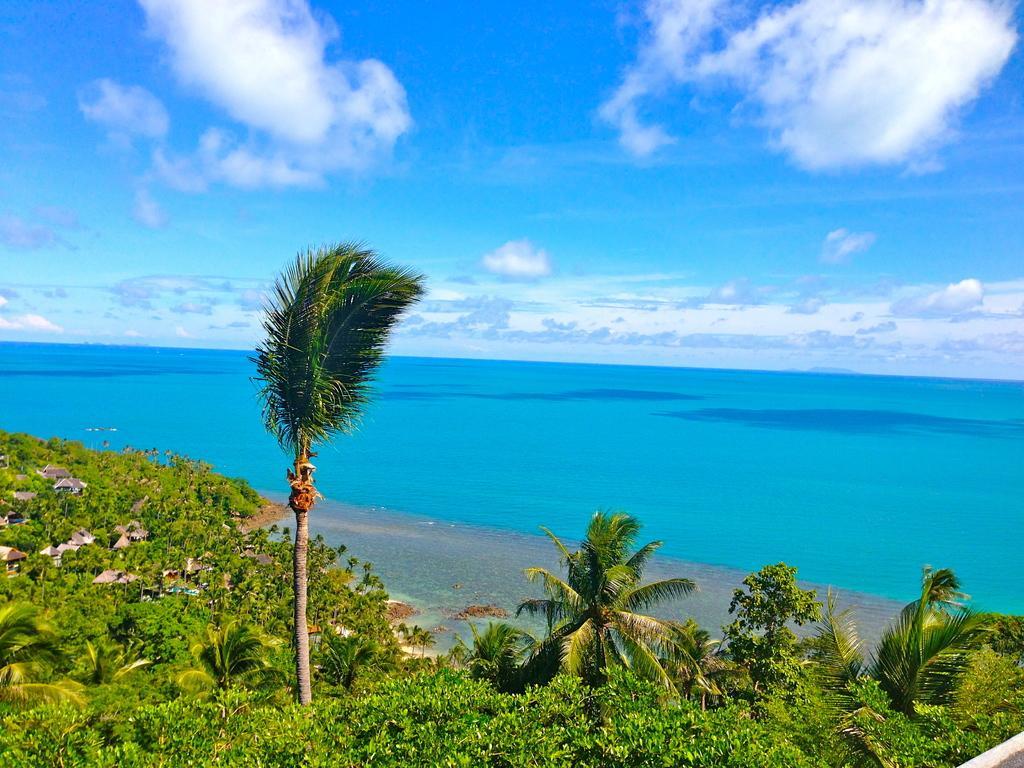Describe this image in one or two sentences. In this picture I can observe trees and plants in the bottom of the picture. In the background I can observe an ocean and sky. 